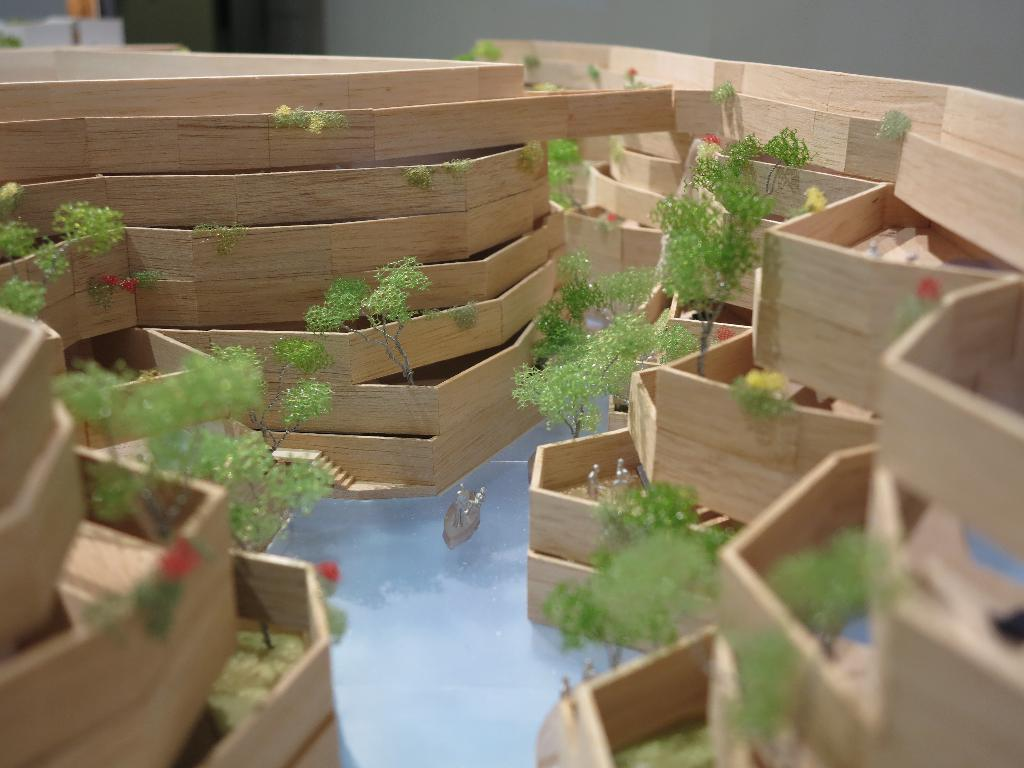What is the main object made of in the image? There is a project-like object made of wood in the image. What type of living organisms can be seen in the image? Plants are visible in the image. Can you describe the surroundings of the project-like object and plants? There are other unspecified things around the project-like object and plants. How many roots can be seen growing from the popcorn in the image? There is no popcorn present in the image, and therefore no roots can be seen growing from it. 